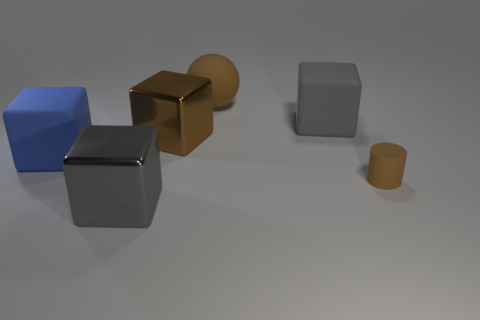What's the lighting condition in this scene? The lighting in this scene seems to be diffused with a hint of directional light coming from the upper left, creating soft shadows on the right sides of the objects. 